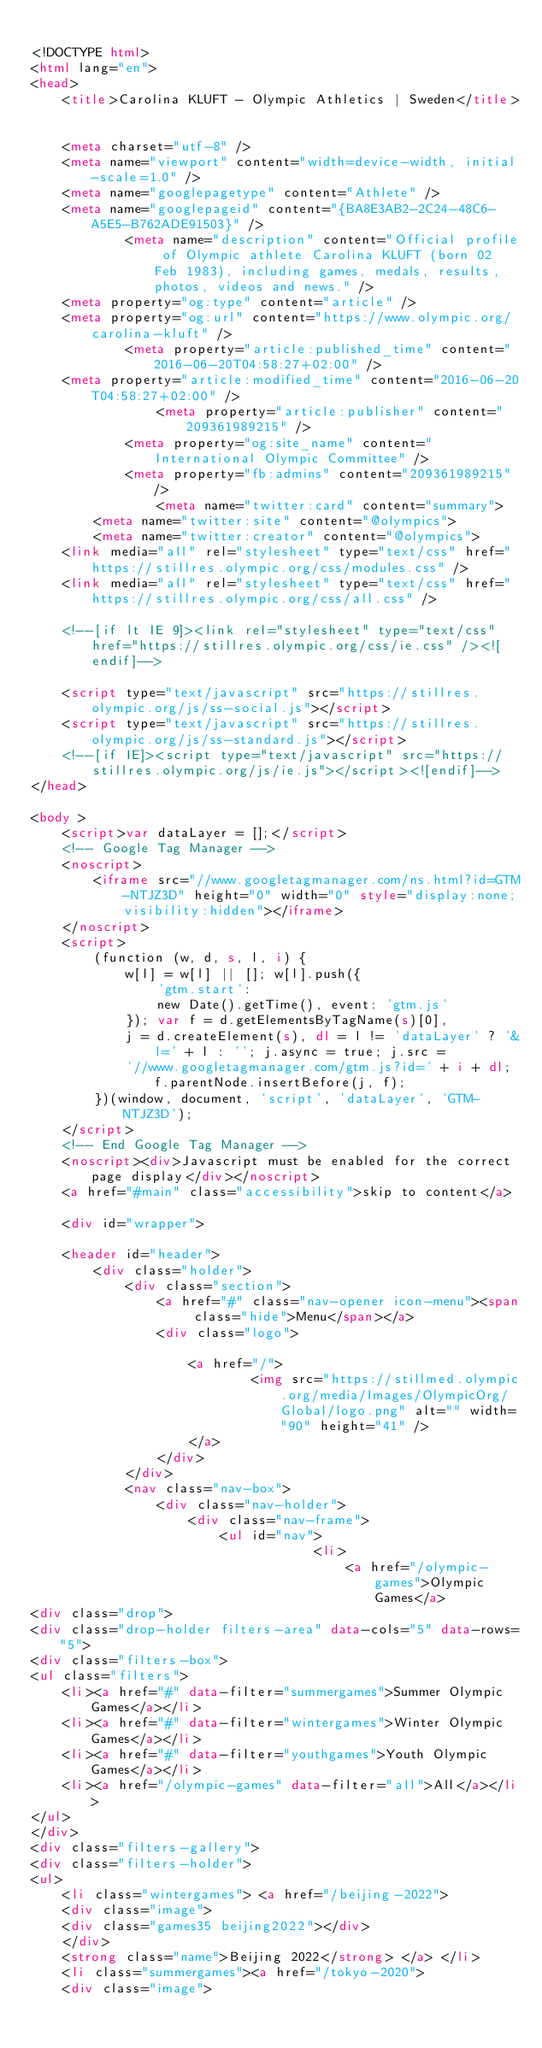Convert code to text. <code><loc_0><loc_0><loc_500><loc_500><_HTML_>
<!DOCTYPE html>
<html lang="en">
<head>
    <title>Carolina KLUFT - Olympic Athletics | Sweden</title>

    
    <meta charset="utf-8" />
    <meta name="viewport" content="width=device-width, initial-scale=1.0" />
    <meta name="googlepagetype" content="Athlete" />
    <meta name="googlepageid" content="{BA8E3AB2-2C24-48C6-A5E5-B762ADE91503}" />
            <meta name="description" content="Official profile of Olympic athlete Carolina KLUFT (born 02 Feb 1983), including games, medals, results, photos, videos and news." />
    <meta property="og:type" content="article" />
    <meta property="og:url" content="https://www.olympic.org/carolina-kluft" />
            <meta property="article:published_time" content="2016-06-20T04:58:27+02:00" />
    <meta property="article:modified_time" content="2016-06-20T04:58:27+02:00" />
                <meta property="article:publisher" content="209361989215" />
            <meta property="og:site_name" content="International Olympic Committee" />
            <meta property="fb:admins" content="209361989215" />
                <meta name="twitter:card" content="summary">
        <meta name="twitter:site" content="@olympics">
        <meta name="twitter:creator" content="@olympics">
    <link media="all" rel="stylesheet" type="text/css" href="https://stillres.olympic.org/css/modules.css" />
    <link media="all" rel="stylesheet" type="text/css" href="https://stillres.olympic.org/css/all.css" />
    
    <!--[if lt IE 9]><link rel="stylesheet" type="text/css" href="https://stillres.olympic.org/css/ie.css" /><![endif]-->
    
    <script type="text/javascript" src="https://stillres.olympic.org/js/ss-social.js"></script>
    <script type="text/javascript" src="https://stillres.olympic.org/js/ss-standard.js"></script>
    <!--[if IE]><script type="text/javascript" src="https://stillres.olympic.org/js/ie.js"></script><![endif]-->
</head>

<body >
    <script>var dataLayer = [];</script>
    <!-- Google Tag Manager -->
    <noscript>
        <iframe src="//www.googletagmanager.com/ns.html?id=GTM-NTJZ3D" height="0" width="0" style="display:none;visibility:hidden"></iframe>
    </noscript>
    <script>
        (function (w, d, s, l, i) {
            w[l] = w[l] || []; w[l].push({
                'gtm.start':
                new Date().getTime(), event: 'gtm.js'
            }); var f = d.getElementsByTagName(s)[0],
            j = d.createElement(s), dl = l != 'dataLayer' ? '&l=' + l : ''; j.async = true; j.src =
            '//www.googletagmanager.com/gtm.js?id=' + i + dl; f.parentNode.insertBefore(j, f);
        })(window, document, 'script', 'dataLayer', 'GTM-NTJZ3D');
    </script>
    <!-- End Google Tag Manager -->
    <noscript><div>Javascript must be enabled for the correct page display</div></noscript>
    <a href="#main" class="accessibility">skip to content</a>
    
    <div id="wrapper">
        
    <header id="header">
        <div class="holder">
            <div class="section">
                <a href="#" class="nav-opener icon-menu"><span class="hide">Menu</span></a>
                <div class="logo">

                    <a href="/">
                            <img src="https://stillmed.olympic.org/media/Images/OlympicOrg/Global/logo.png" alt="" width="90" height="41" />
                    </a>
                </div>
            </div>
            <nav class="nav-box">
                <div class="nav-holder">
                    <div class="nav-frame">
                        <ul id="nav">
                                    <li>
                                        <a href="/olympic-games">Olympic Games</a>
<div class="drop">
<div class="drop-holder filters-area" data-cols="5" data-rows="5">
<div class="filters-box">
<ul class="filters">
    <li><a href="#" data-filter="summergames">Summer Olympic Games</a></li>
    <li><a href="#" data-filter="wintergames">Winter Olympic Games</a></li>
    <li><a href="#" data-filter="youthgames">Youth Olympic Games</a></li>
    <li><a href="/olympic-games" data-filter="all">All</a></li>
</ul>
</div>
<div class="filters-gallery">
<div class="filters-holder">
<ul>
    <li class="wintergames"> <a href="/beijing-2022">
    <div class="image">
    <div class="games35 beijing2022"></div>
    </div>
    <strong class="name">Beijing 2022</strong> </a> </li>
    <li class="summergames"><a href="/tokyo-2020">
    <div class="image"></code> 